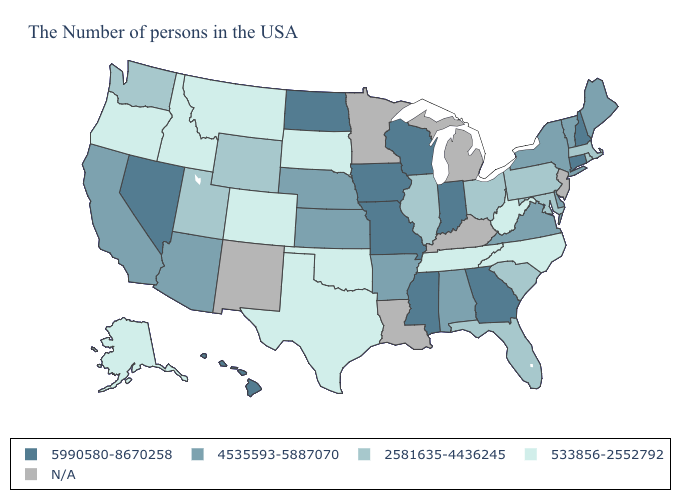Does the map have missing data?
Keep it brief. Yes. Does the first symbol in the legend represent the smallest category?
Concise answer only. No. Does the map have missing data?
Short answer required. Yes. Which states have the lowest value in the USA?
Write a very short answer. North Carolina, West Virginia, Tennessee, Oklahoma, Texas, South Dakota, Colorado, Montana, Idaho, Oregon, Alaska. What is the lowest value in the MidWest?
Quick response, please. 533856-2552792. Which states have the highest value in the USA?
Quick response, please. New Hampshire, Connecticut, Georgia, Indiana, Wisconsin, Mississippi, Missouri, Iowa, North Dakota, Nevada, Hawaii. Name the states that have a value in the range 5990580-8670258?
Short answer required. New Hampshire, Connecticut, Georgia, Indiana, Wisconsin, Mississippi, Missouri, Iowa, North Dakota, Nevada, Hawaii. What is the value of Colorado?
Answer briefly. 533856-2552792. Among the states that border Kentucky , which have the highest value?
Write a very short answer. Indiana, Missouri. Which states have the lowest value in the MidWest?
Concise answer only. South Dakota. Name the states that have a value in the range 2581635-4436245?
Keep it brief. Massachusetts, Rhode Island, Maryland, Pennsylvania, South Carolina, Ohio, Florida, Illinois, Wyoming, Utah, Washington. Is the legend a continuous bar?
Quick response, please. No. What is the value of Massachusetts?
Be succinct. 2581635-4436245. What is the value of South Carolina?
Keep it brief. 2581635-4436245. 